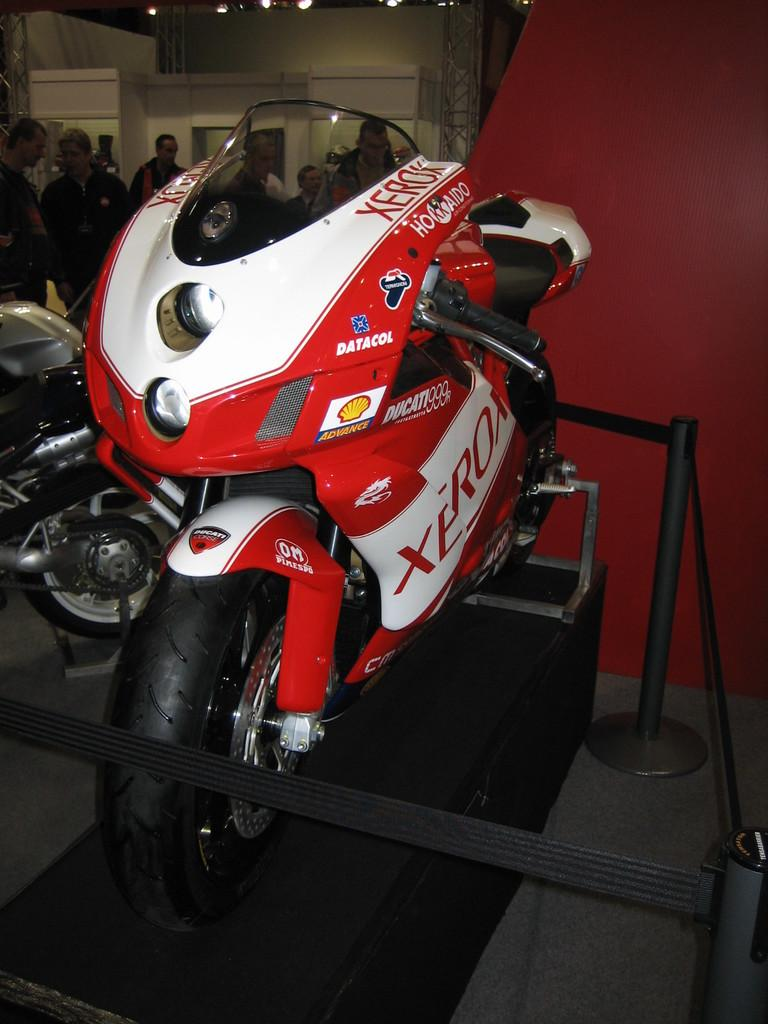What is the main subject in the foreground of the picture? There is a bike in the foreground of the picture. How is the bike positioned in the image? The bike is placed on a stand. Are there any other bikes visible in the image? Yes, there is another bike on the left side of the image. What can be seen in the background of the image? There are people, lights, and a construction site in the background. What type of bird can be seen perched on the wrist of one of the people in the image? There is no bird visible in the image, let alone one perched on someone's wrist. 